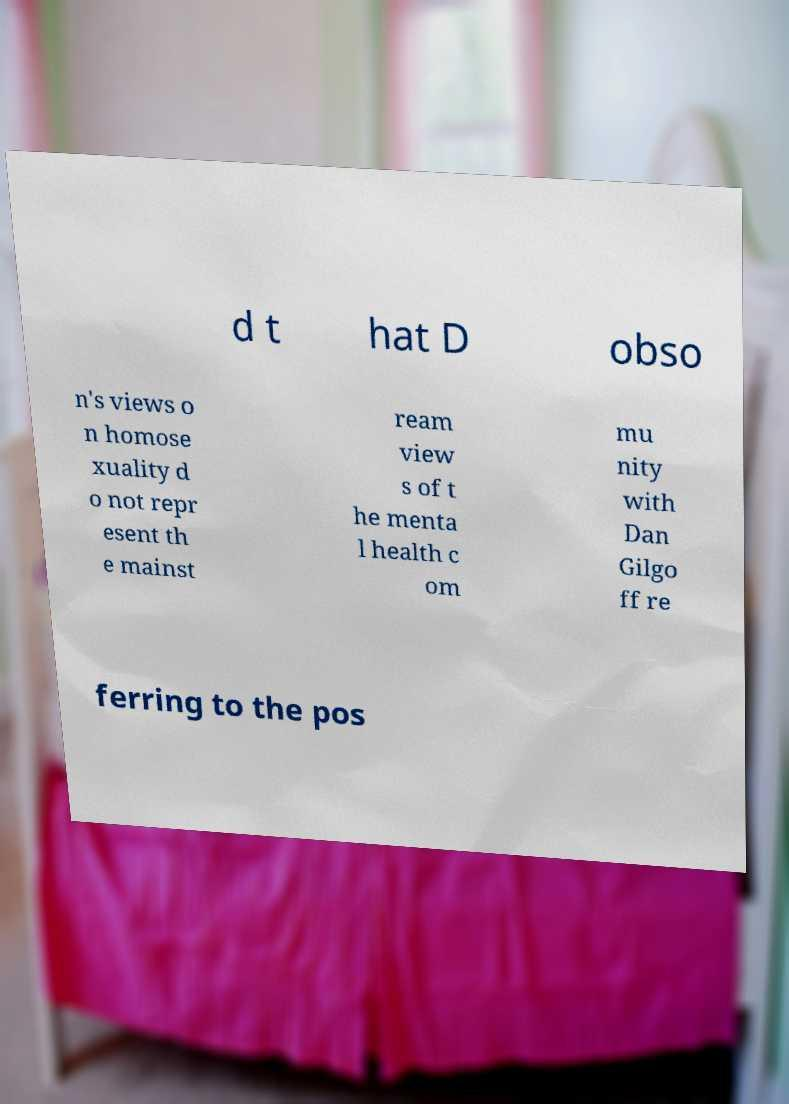For documentation purposes, I need the text within this image transcribed. Could you provide that? d t hat D obso n's views o n homose xuality d o not repr esent th e mainst ream view s of t he menta l health c om mu nity with Dan Gilgo ff re ferring to the pos 